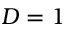<formula> <loc_0><loc_0><loc_500><loc_500>D = 1</formula> 